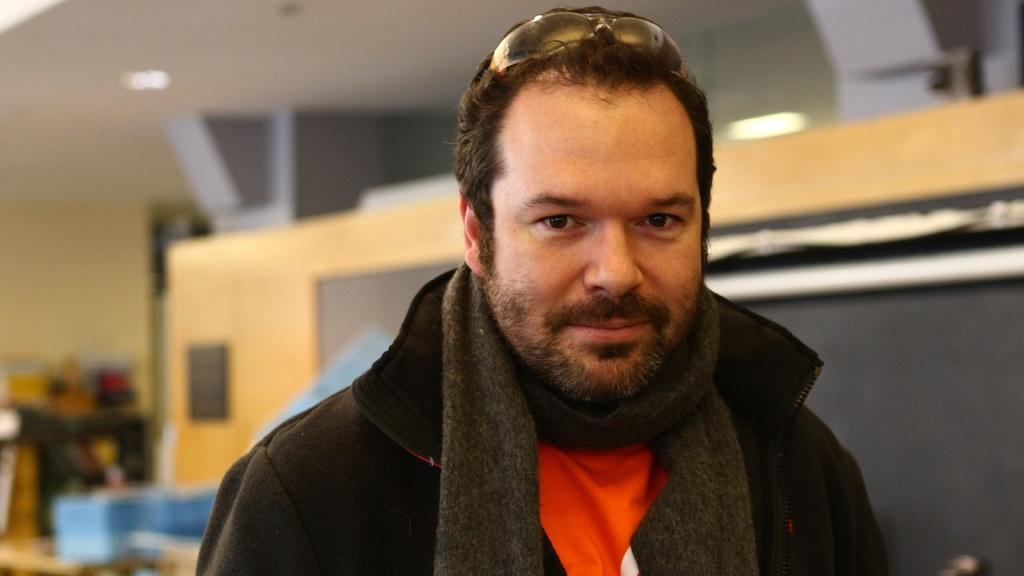Describe this image in one or two sentences. In this image there is a person in the blurred background 